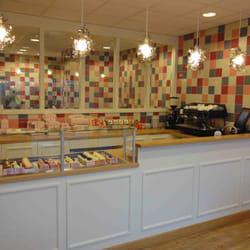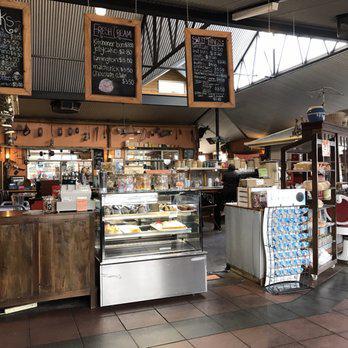The first image is the image on the left, the second image is the image on the right. Considering the images on both sides, is "There are tables and chairs for dining in at least one of the images, but there are no people." valid? Answer yes or no. No. The first image is the image on the left, the second image is the image on the right. For the images shown, is this caption "The interior of a shop has a row of suspended white lights over a pale painted counter with glass display case on top." true? Answer yes or no. Yes. 